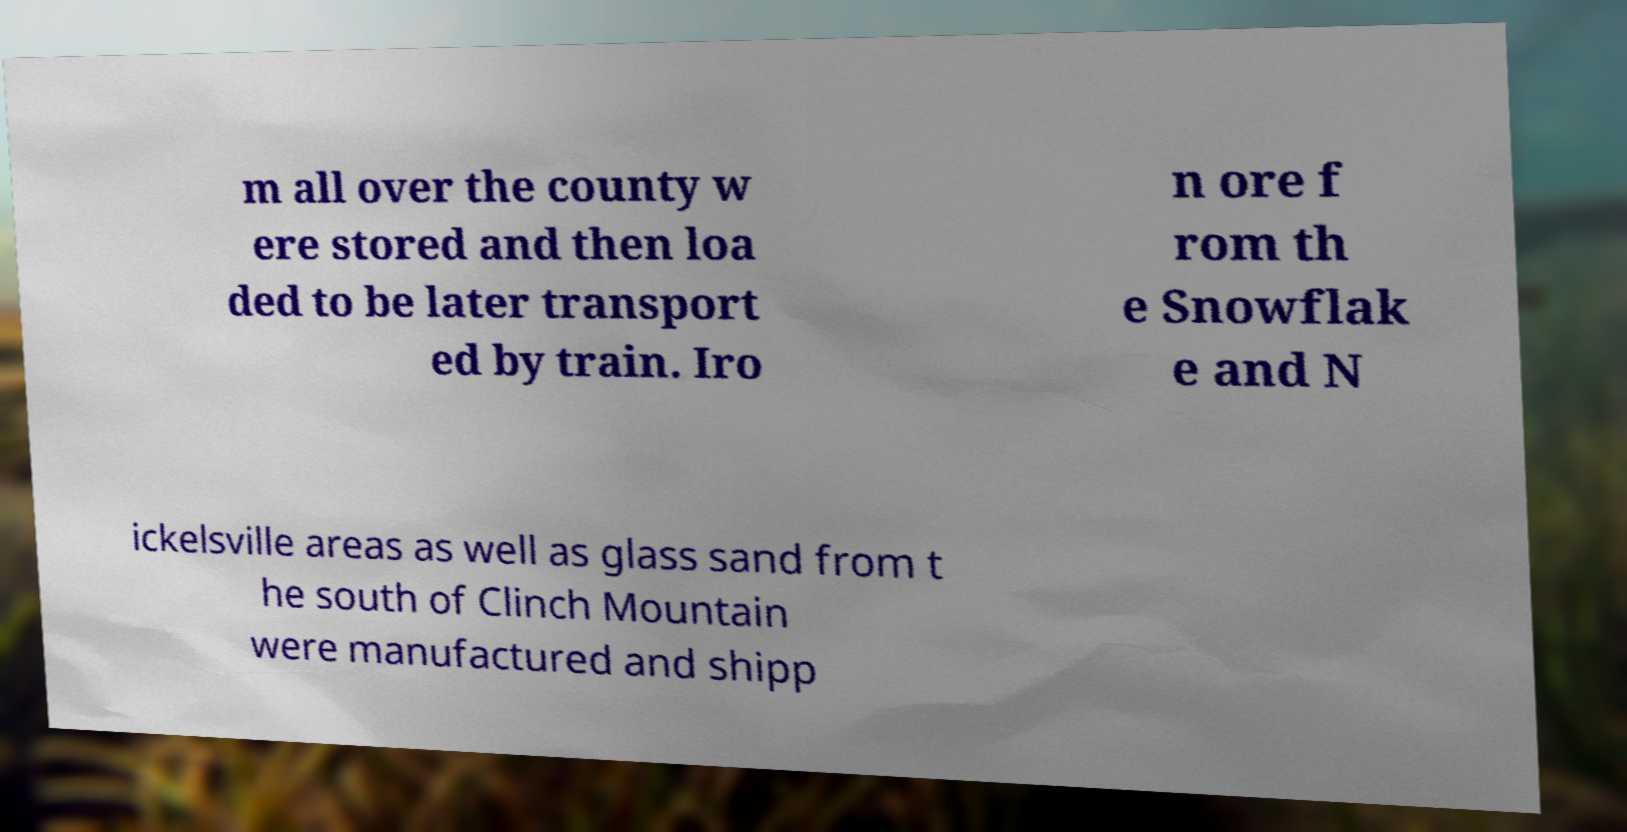I need the written content from this picture converted into text. Can you do that? m all over the county w ere stored and then loa ded to be later transport ed by train. Iro n ore f rom th e Snowflak e and N ickelsville areas as well as glass sand from t he south of Clinch Mountain were manufactured and shipp 